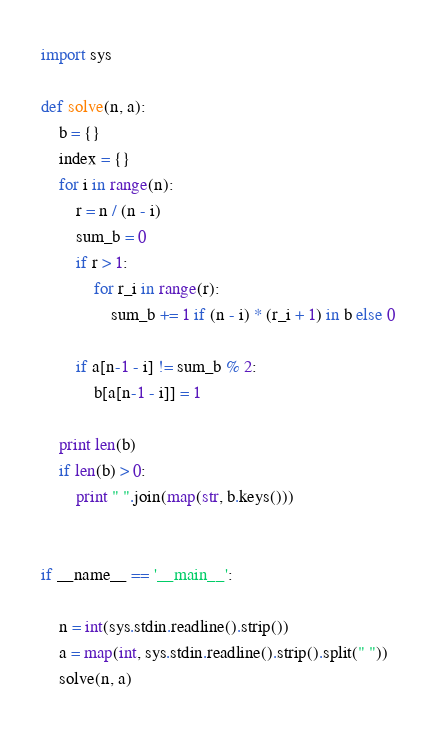<code> <loc_0><loc_0><loc_500><loc_500><_Python_>import sys

def solve(n, a):
    b = {}
    index = {}
    for i in range(n):
        r = n / (n - i)
        sum_b = 0
        if r > 1:
            for r_i in range(r):
                sum_b += 1 if (n - i) * (r_i + 1) in b else 0

        if a[n-1 - i] != sum_b % 2:
            b[a[n-1 - i]] = 1

    print len(b)
    if len(b) > 0:
        print " ".join(map(str, b.keys()))


if __name__ == '__main__':

    n = int(sys.stdin.readline().strip())
    a = map(int, sys.stdin.readline().strip().split(" "))
    solve(n, a)</code> 